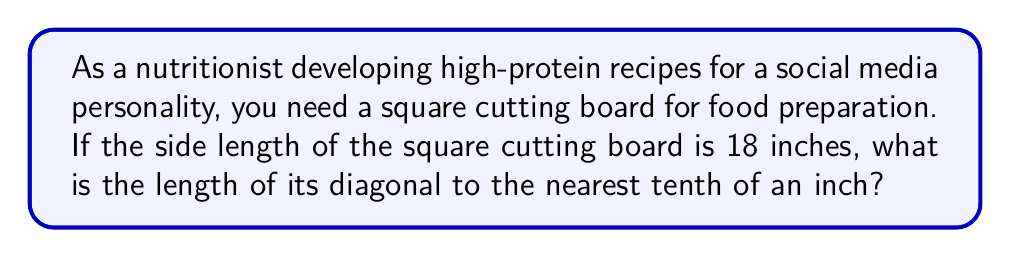Provide a solution to this math problem. Let's approach this step-by-step:

1) In a square, the diagonal forms the hypotenuse of a right triangle where the other two sides are the sides of the square.

2) We can use the Pythagorean theorem to find the length of the diagonal. The Pythagorean theorem states that in a right triangle, $a^2 + b^2 = c^2$, where c is the hypotenuse.

3) In this case, both sides of the square (and thus the legs of the right triangle) are 18 inches. Let's call the diagonal length d. We can set up the equation:

   $18^2 + 18^2 = d^2$

4) Simplify the left side:
   $324 + 324 = d^2$
   $648 = d^2$

5) To solve for d, we need to take the square root of both sides:
   $\sqrt{648} = d$

6) Simplify the square root:
   $\sqrt{648} = \sqrt{16 * 40.5} = 4\sqrt{40.5} \approx 25.4558$ inches

7) Rounding to the nearest tenth:
   25.4558 rounds to 25.5 inches

[asy]
unitsize(0.2 inch);
path square = (0,0)--(8,0)--(8,8)--(0,8)--cycle;
draw(square);
draw((0,0)--(8,8), red);
label("18", (4,-0.5));
label("18", (8.5,4));
label("d", (3,5));
[/asy]
Answer: $25.5$ inches 